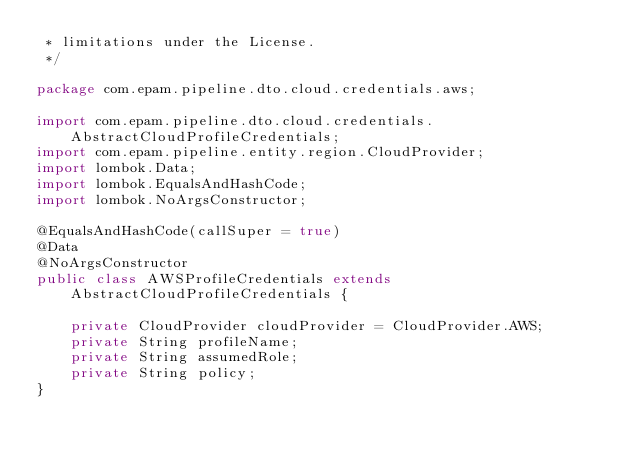<code> <loc_0><loc_0><loc_500><loc_500><_Java_> * limitations under the License.
 */

package com.epam.pipeline.dto.cloud.credentials.aws;

import com.epam.pipeline.dto.cloud.credentials.AbstractCloudProfileCredentials;
import com.epam.pipeline.entity.region.CloudProvider;
import lombok.Data;
import lombok.EqualsAndHashCode;
import lombok.NoArgsConstructor;

@EqualsAndHashCode(callSuper = true)
@Data
@NoArgsConstructor
public class AWSProfileCredentials extends AbstractCloudProfileCredentials {

    private CloudProvider cloudProvider = CloudProvider.AWS;
    private String profileName;
    private String assumedRole;
    private String policy;
}
</code> 